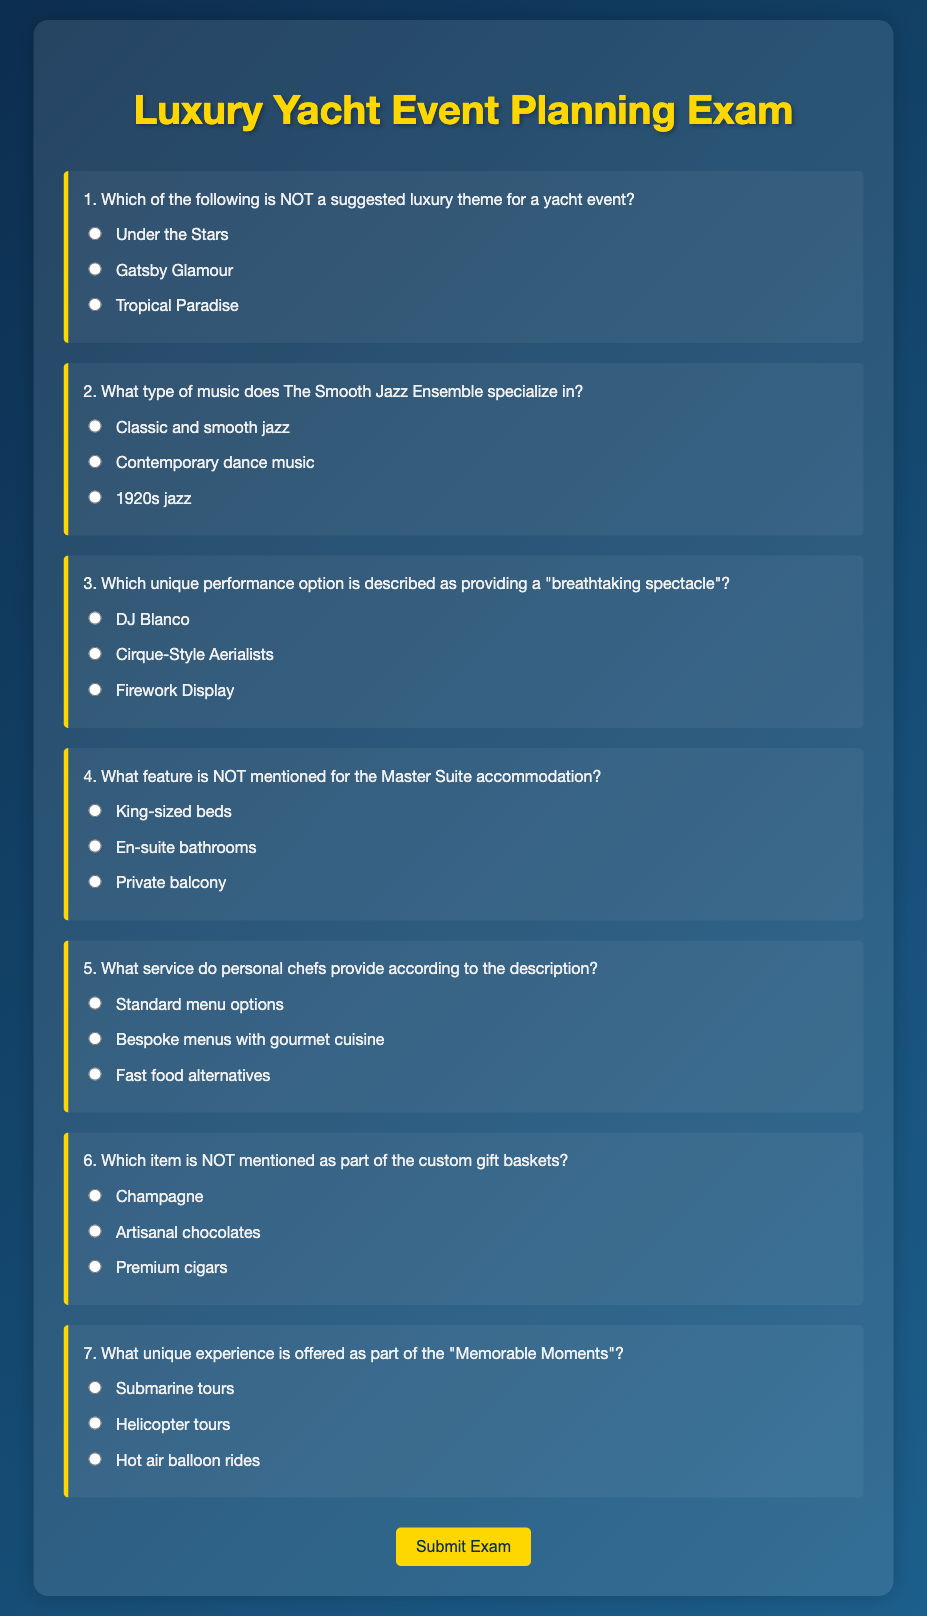What is the title of the document? The title is prominently displayed at the top of the page, indicating the content focuses on event planning in the luxury yacht sector.
Answer: Luxury Yacht Event Planning Exam How many suggested luxury themes are listed in the document? The document contains a multiple-choice question about suggested themes, implying there are at least three themes presented.
Answer: Three What type of music does The Smooth Jazz Ensemble specialize in? The document provides options related to music genres, specifically mentioning smooth jazz, which is indicative of the ensemble's specialty.
Answer: Classic and smooth jazz Which unique performance option is described as providing a "breathtaking spectacle"? The document includes multiple-choice answers that describe performance options, one of which is explicitly labeled with the term "breathtaking spectacle."
Answer: Cirque-Style Aerialists What service do personal chefs provide according to the description? The document presents options regarding the type of service personal chefs offer, distinctly highlighting the gourmet aspect of their menus.
Answer: Bespoke menus with gourmet cuisine Which item is NOT mentioned as part of the custom gift baskets? The document includes a question about items in gift baskets, suggesting there are specific items listed; one option among them is incorrect.
Answer: Premium cigars What unique experience is offered as part of the "Memorable Moments"? The document outlines various experiences and one specific unique offering is highlighted as part of memorable moments.
Answer: Helicopter tours 